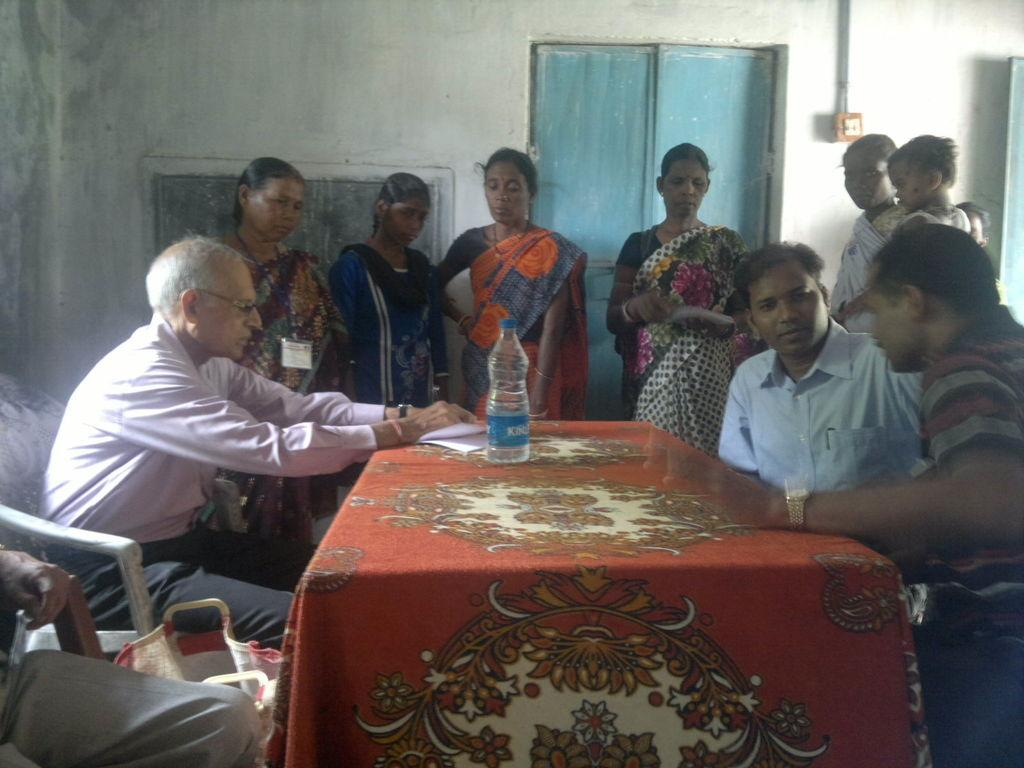How many people are in the image? There is a group of people in the image, but the exact number is not specified. What are the people doing in the image? Some people are standing, while others are sitting, and they are gathered around a table. What can be seen on the table in the image? There is a bottle and papers on the table. What is located at the center of the image? There is a door at the center of the image. What type of canvas is being used by the people in the image? There is no canvas present in the image; the people are gathered around a table with a bottle and papers. What question is being asked by the person holding the quartz in the image? There is no person holding quartz in the image, and no question is being asked. 